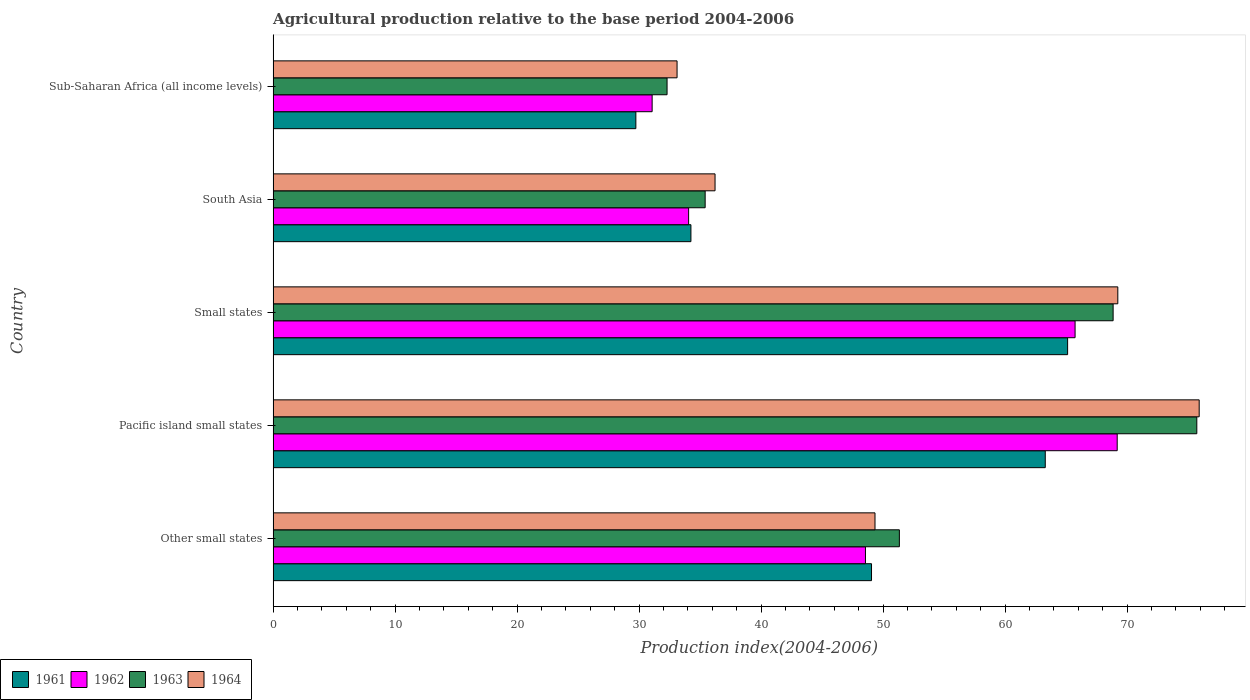How many different coloured bars are there?
Offer a very short reply. 4. How many groups of bars are there?
Offer a terse response. 5. Are the number of bars on each tick of the Y-axis equal?
Offer a terse response. Yes. How many bars are there on the 1st tick from the top?
Offer a terse response. 4. How many bars are there on the 2nd tick from the bottom?
Your response must be concise. 4. What is the label of the 3rd group of bars from the top?
Your response must be concise. Small states. In how many cases, is the number of bars for a given country not equal to the number of legend labels?
Your response must be concise. 0. What is the agricultural production index in 1963 in Other small states?
Ensure brevity in your answer.  51.34. Across all countries, what is the maximum agricultural production index in 1961?
Offer a very short reply. 65.13. Across all countries, what is the minimum agricultural production index in 1962?
Give a very brief answer. 31.07. In which country was the agricultural production index in 1963 maximum?
Give a very brief answer. Pacific island small states. In which country was the agricultural production index in 1961 minimum?
Offer a terse response. Sub-Saharan Africa (all income levels). What is the total agricultural production index in 1961 in the graph?
Offer a terse response. 241.47. What is the difference between the agricultural production index in 1963 in Pacific island small states and that in South Asia?
Provide a short and direct response. 40.31. What is the difference between the agricultural production index in 1963 in Sub-Saharan Africa (all income levels) and the agricultural production index in 1961 in Pacific island small states?
Ensure brevity in your answer.  -31. What is the average agricultural production index in 1963 per country?
Provide a short and direct response. 52.73. What is the difference between the agricultural production index in 1964 and agricultural production index in 1962 in Sub-Saharan Africa (all income levels)?
Make the answer very short. 2.04. In how many countries, is the agricultural production index in 1963 greater than 44 ?
Make the answer very short. 3. What is the ratio of the agricultural production index in 1963 in Small states to that in South Asia?
Your answer should be very brief. 1.94. Is the agricultural production index in 1962 in Other small states less than that in Pacific island small states?
Give a very brief answer. Yes. Is the difference between the agricultural production index in 1964 in Small states and Sub-Saharan Africa (all income levels) greater than the difference between the agricultural production index in 1962 in Small states and Sub-Saharan Africa (all income levels)?
Your answer should be compact. Yes. What is the difference between the highest and the second highest agricultural production index in 1961?
Your answer should be compact. 1.83. What is the difference between the highest and the lowest agricultural production index in 1961?
Offer a terse response. 35.39. In how many countries, is the agricultural production index in 1961 greater than the average agricultural production index in 1961 taken over all countries?
Your answer should be very brief. 3. Is it the case that in every country, the sum of the agricultural production index in 1964 and agricultural production index in 1963 is greater than the agricultural production index in 1961?
Provide a short and direct response. Yes. How many bars are there?
Give a very brief answer. 20. How many countries are there in the graph?
Offer a very short reply. 5. What is the difference between two consecutive major ticks on the X-axis?
Ensure brevity in your answer.  10. Does the graph contain any zero values?
Your answer should be compact. No. How are the legend labels stacked?
Your response must be concise. Horizontal. What is the title of the graph?
Ensure brevity in your answer.  Agricultural production relative to the base period 2004-2006. Does "1977" appear as one of the legend labels in the graph?
Your answer should be very brief. No. What is the label or title of the X-axis?
Offer a very short reply. Production index(2004-2006). What is the label or title of the Y-axis?
Offer a terse response. Country. What is the Production index(2004-2006) in 1961 in Other small states?
Offer a terse response. 49.06. What is the Production index(2004-2006) of 1962 in Other small states?
Your answer should be very brief. 48.56. What is the Production index(2004-2006) of 1963 in Other small states?
Offer a terse response. 51.34. What is the Production index(2004-2006) in 1964 in Other small states?
Give a very brief answer. 49.34. What is the Production index(2004-2006) of 1961 in Pacific island small states?
Give a very brief answer. 63.3. What is the Production index(2004-2006) of 1962 in Pacific island small states?
Offer a very short reply. 69.2. What is the Production index(2004-2006) of 1963 in Pacific island small states?
Keep it short and to the point. 75.72. What is the Production index(2004-2006) in 1964 in Pacific island small states?
Ensure brevity in your answer.  75.92. What is the Production index(2004-2006) in 1961 in Small states?
Your answer should be compact. 65.13. What is the Production index(2004-2006) in 1962 in Small states?
Ensure brevity in your answer.  65.74. What is the Production index(2004-2006) of 1963 in Small states?
Offer a very short reply. 68.86. What is the Production index(2004-2006) in 1964 in Small states?
Provide a short and direct response. 69.25. What is the Production index(2004-2006) of 1961 in South Asia?
Provide a succinct answer. 34.25. What is the Production index(2004-2006) of 1962 in South Asia?
Make the answer very short. 34.06. What is the Production index(2004-2006) in 1963 in South Asia?
Your answer should be very brief. 35.42. What is the Production index(2004-2006) of 1964 in South Asia?
Offer a terse response. 36.23. What is the Production index(2004-2006) of 1961 in Sub-Saharan Africa (all income levels)?
Ensure brevity in your answer.  29.74. What is the Production index(2004-2006) of 1962 in Sub-Saharan Africa (all income levels)?
Make the answer very short. 31.07. What is the Production index(2004-2006) in 1963 in Sub-Saharan Africa (all income levels)?
Ensure brevity in your answer.  32.29. What is the Production index(2004-2006) of 1964 in Sub-Saharan Africa (all income levels)?
Offer a terse response. 33.11. Across all countries, what is the maximum Production index(2004-2006) of 1961?
Make the answer very short. 65.13. Across all countries, what is the maximum Production index(2004-2006) of 1962?
Your response must be concise. 69.2. Across all countries, what is the maximum Production index(2004-2006) of 1963?
Provide a succinct answer. 75.72. Across all countries, what is the maximum Production index(2004-2006) of 1964?
Your answer should be very brief. 75.92. Across all countries, what is the minimum Production index(2004-2006) of 1961?
Offer a terse response. 29.74. Across all countries, what is the minimum Production index(2004-2006) in 1962?
Provide a short and direct response. 31.07. Across all countries, what is the minimum Production index(2004-2006) in 1963?
Provide a short and direct response. 32.29. Across all countries, what is the minimum Production index(2004-2006) in 1964?
Your answer should be compact. 33.11. What is the total Production index(2004-2006) in 1961 in the graph?
Your response must be concise. 241.47. What is the total Production index(2004-2006) in 1962 in the graph?
Keep it short and to the point. 248.63. What is the total Production index(2004-2006) in 1963 in the graph?
Provide a succinct answer. 263.64. What is the total Production index(2004-2006) in 1964 in the graph?
Make the answer very short. 263.85. What is the difference between the Production index(2004-2006) of 1961 in Other small states and that in Pacific island small states?
Provide a short and direct response. -14.24. What is the difference between the Production index(2004-2006) in 1962 in Other small states and that in Pacific island small states?
Make the answer very short. -20.64. What is the difference between the Production index(2004-2006) in 1963 in Other small states and that in Pacific island small states?
Provide a short and direct response. -24.38. What is the difference between the Production index(2004-2006) of 1964 in Other small states and that in Pacific island small states?
Your answer should be compact. -26.58. What is the difference between the Production index(2004-2006) in 1961 in Other small states and that in Small states?
Ensure brevity in your answer.  -16.08. What is the difference between the Production index(2004-2006) of 1962 in Other small states and that in Small states?
Provide a succinct answer. -17.18. What is the difference between the Production index(2004-2006) of 1963 in Other small states and that in Small states?
Your response must be concise. -17.52. What is the difference between the Production index(2004-2006) in 1964 in Other small states and that in Small states?
Keep it short and to the point. -19.91. What is the difference between the Production index(2004-2006) of 1961 in Other small states and that in South Asia?
Keep it short and to the point. 14.81. What is the difference between the Production index(2004-2006) of 1962 in Other small states and that in South Asia?
Keep it short and to the point. 14.5. What is the difference between the Production index(2004-2006) of 1963 in Other small states and that in South Asia?
Offer a terse response. 15.92. What is the difference between the Production index(2004-2006) of 1964 in Other small states and that in South Asia?
Your answer should be very brief. 13.11. What is the difference between the Production index(2004-2006) of 1961 in Other small states and that in Sub-Saharan Africa (all income levels)?
Ensure brevity in your answer.  19.32. What is the difference between the Production index(2004-2006) of 1962 in Other small states and that in Sub-Saharan Africa (all income levels)?
Give a very brief answer. 17.49. What is the difference between the Production index(2004-2006) of 1963 in Other small states and that in Sub-Saharan Africa (all income levels)?
Your answer should be very brief. 19.04. What is the difference between the Production index(2004-2006) of 1964 in Other small states and that in Sub-Saharan Africa (all income levels)?
Offer a very short reply. 16.23. What is the difference between the Production index(2004-2006) in 1961 in Pacific island small states and that in Small states?
Provide a succinct answer. -1.83. What is the difference between the Production index(2004-2006) of 1962 in Pacific island small states and that in Small states?
Ensure brevity in your answer.  3.45. What is the difference between the Production index(2004-2006) of 1963 in Pacific island small states and that in Small states?
Offer a very short reply. 6.86. What is the difference between the Production index(2004-2006) in 1964 in Pacific island small states and that in Small states?
Your answer should be compact. 6.67. What is the difference between the Production index(2004-2006) of 1961 in Pacific island small states and that in South Asia?
Provide a succinct answer. 29.05. What is the difference between the Production index(2004-2006) in 1962 in Pacific island small states and that in South Asia?
Provide a short and direct response. 35.13. What is the difference between the Production index(2004-2006) in 1963 in Pacific island small states and that in South Asia?
Your answer should be compact. 40.31. What is the difference between the Production index(2004-2006) of 1964 in Pacific island small states and that in South Asia?
Provide a succinct answer. 39.69. What is the difference between the Production index(2004-2006) in 1961 in Pacific island small states and that in Sub-Saharan Africa (all income levels)?
Your response must be concise. 33.56. What is the difference between the Production index(2004-2006) in 1962 in Pacific island small states and that in Sub-Saharan Africa (all income levels)?
Your answer should be compact. 38.12. What is the difference between the Production index(2004-2006) in 1963 in Pacific island small states and that in Sub-Saharan Africa (all income levels)?
Ensure brevity in your answer.  43.43. What is the difference between the Production index(2004-2006) of 1964 in Pacific island small states and that in Sub-Saharan Africa (all income levels)?
Provide a short and direct response. 42.8. What is the difference between the Production index(2004-2006) of 1961 in Small states and that in South Asia?
Ensure brevity in your answer.  30.88. What is the difference between the Production index(2004-2006) of 1962 in Small states and that in South Asia?
Give a very brief answer. 31.68. What is the difference between the Production index(2004-2006) of 1963 in Small states and that in South Asia?
Offer a terse response. 33.45. What is the difference between the Production index(2004-2006) of 1964 in Small states and that in South Asia?
Make the answer very short. 33.02. What is the difference between the Production index(2004-2006) in 1961 in Small states and that in Sub-Saharan Africa (all income levels)?
Your answer should be compact. 35.39. What is the difference between the Production index(2004-2006) of 1962 in Small states and that in Sub-Saharan Africa (all income levels)?
Offer a terse response. 34.67. What is the difference between the Production index(2004-2006) in 1963 in Small states and that in Sub-Saharan Africa (all income levels)?
Offer a very short reply. 36.57. What is the difference between the Production index(2004-2006) in 1964 in Small states and that in Sub-Saharan Africa (all income levels)?
Make the answer very short. 36.13. What is the difference between the Production index(2004-2006) of 1961 in South Asia and that in Sub-Saharan Africa (all income levels)?
Ensure brevity in your answer.  4.51. What is the difference between the Production index(2004-2006) in 1962 in South Asia and that in Sub-Saharan Africa (all income levels)?
Ensure brevity in your answer.  2.99. What is the difference between the Production index(2004-2006) of 1963 in South Asia and that in Sub-Saharan Africa (all income levels)?
Give a very brief answer. 3.12. What is the difference between the Production index(2004-2006) in 1964 in South Asia and that in Sub-Saharan Africa (all income levels)?
Your response must be concise. 3.11. What is the difference between the Production index(2004-2006) in 1961 in Other small states and the Production index(2004-2006) in 1962 in Pacific island small states?
Your answer should be compact. -20.14. What is the difference between the Production index(2004-2006) in 1961 in Other small states and the Production index(2004-2006) in 1963 in Pacific island small states?
Keep it short and to the point. -26.67. What is the difference between the Production index(2004-2006) of 1961 in Other small states and the Production index(2004-2006) of 1964 in Pacific island small states?
Offer a terse response. -26.86. What is the difference between the Production index(2004-2006) in 1962 in Other small states and the Production index(2004-2006) in 1963 in Pacific island small states?
Ensure brevity in your answer.  -27.16. What is the difference between the Production index(2004-2006) in 1962 in Other small states and the Production index(2004-2006) in 1964 in Pacific island small states?
Offer a terse response. -27.36. What is the difference between the Production index(2004-2006) of 1963 in Other small states and the Production index(2004-2006) of 1964 in Pacific island small states?
Offer a terse response. -24.58. What is the difference between the Production index(2004-2006) in 1961 in Other small states and the Production index(2004-2006) in 1962 in Small states?
Your answer should be very brief. -16.69. What is the difference between the Production index(2004-2006) of 1961 in Other small states and the Production index(2004-2006) of 1963 in Small states?
Offer a very short reply. -19.81. What is the difference between the Production index(2004-2006) in 1961 in Other small states and the Production index(2004-2006) in 1964 in Small states?
Give a very brief answer. -20.19. What is the difference between the Production index(2004-2006) of 1962 in Other small states and the Production index(2004-2006) of 1963 in Small states?
Ensure brevity in your answer.  -20.3. What is the difference between the Production index(2004-2006) of 1962 in Other small states and the Production index(2004-2006) of 1964 in Small states?
Keep it short and to the point. -20.69. What is the difference between the Production index(2004-2006) of 1963 in Other small states and the Production index(2004-2006) of 1964 in Small states?
Give a very brief answer. -17.91. What is the difference between the Production index(2004-2006) of 1961 in Other small states and the Production index(2004-2006) of 1962 in South Asia?
Give a very brief answer. 14.99. What is the difference between the Production index(2004-2006) of 1961 in Other small states and the Production index(2004-2006) of 1963 in South Asia?
Keep it short and to the point. 13.64. What is the difference between the Production index(2004-2006) in 1961 in Other small states and the Production index(2004-2006) in 1964 in South Asia?
Offer a very short reply. 12.83. What is the difference between the Production index(2004-2006) in 1962 in Other small states and the Production index(2004-2006) in 1963 in South Asia?
Your answer should be very brief. 13.14. What is the difference between the Production index(2004-2006) in 1962 in Other small states and the Production index(2004-2006) in 1964 in South Asia?
Provide a succinct answer. 12.33. What is the difference between the Production index(2004-2006) in 1963 in Other small states and the Production index(2004-2006) in 1964 in South Asia?
Your answer should be compact. 15.11. What is the difference between the Production index(2004-2006) of 1961 in Other small states and the Production index(2004-2006) of 1962 in Sub-Saharan Africa (all income levels)?
Give a very brief answer. 17.98. What is the difference between the Production index(2004-2006) in 1961 in Other small states and the Production index(2004-2006) in 1963 in Sub-Saharan Africa (all income levels)?
Provide a short and direct response. 16.76. What is the difference between the Production index(2004-2006) of 1961 in Other small states and the Production index(2004-2006) of 1964 in Sub-Saharan Africa (all income levels)?
Give a very brief answer. 15.94. What is the difference between the Production index(2004-2006) of 1962 in Other small states and the Production index(2004-2006) of 1963 in Sub-Saharan Africa (all income levels)?
Your answer should be very brief. 16.27. What is the difference between the Production index(2004-2006) in 1962 in Other small states and the Production index(2004-2006) in 1964 in Sub-Saharan Africa (all income levels)?
Make the answer very short. 15.45. What is the difference between the Production index(2004-2006) of 1963 in Other small states and the Production index(2004-2006) of 1964 in Sub-Saharan Africa (all income levels)?
Make the answer very short. 18.22. What is the difference between the Production index(2004-2006) in 1961 in Pacific island small states and the Production index(2004-2006) in 1962 in Small states?
Keep it short and to the point. -2.44. What is the difference between the Production index(2004-2006) of 1961 in Pacific island small states and the Production index(2004-2006) of 1963 in Small states?
Ensure brevity in your answer.  -5.56. What is the difference between the Production index(2004-2006) of 1961 in Pacific island small states and the Production index(2004-2006) of 1964 in Small states?
Ensure brevity in your answer.  -5.95. What is the difference between the Production index(2004-2006) in 1962 in Pacific island small states and the Production index(2004-2006) in 1963 in Small states?
Provide a succinct answer. 0.33. What is the difference between the Production index(2004-2006) in 1962 in Pacific island small states and the Production index(2004-2006) in 1964 in Small states?
Offer a very short reply. -0.05. What is the difference between the Production index(2004-2006) of 1963 in Pacific island small states and the Production index(2004-2006) of 1964 in Small states?
Ensure brevity in your answer.  6.48. What is the difference between the Production index(2004-2006) in 1961 in Pacific island small states and the Production index(2004-2006) in 1962 in South Asia?
Make the answer very short. 29.24. What is the difference between the Production index(2004-2006) of 1961 in Pacific island small states and the Production index(2004-2006) of 1963 in South Asia?
Make the answer very short. 27.88. What is the difference between the Production index(2004-2006) in 1961 in Pacific island small states and the Production index(2004-2006) in 1964 in South Asia?
Keep it short and to the point. 27.07. What is the difference between the Production index(2004-2006) in 1962 in Pacific island small states and the Production index(2004-2006) in 1963 in South Asia?
Give a very brief answer. 33.78. What is the difference between the Production index(2004-2006) in 1962 in Pacific island small states and the Production index(2004-2006) in 1964 in South Asia?
Make the answer very short. 32.97. What is the difference between the Production index(2004-2006) of 1963 in Pacific island small states and the Production index(2004-2006) of 1964 in South Asia?
Ensure brevity in your answer.  39.49. What is the difference between the Production index(2004-2006) of 1961 in Pacific island small states and the Production index(2004-2006) of 1962 in Sub-Saharan Africa (all income levels)?
Provide a succinct answer. 32.23. What is the difference between the Production index(2004-2006) of 1961 in Pacific island small states and the Production index(2004-2006) of 1963 in Sub-Saharan Africa (all income levels)?
Offer a terse response. 31. What is the difference between the Production index(2004-2006) of 1961 in Pacific island small states and the Production index(2004-2006) of 1964 in Sub-Saharan Africa (all income levels)?
Give a very brief answer. 30.18. What is the difference between the Production index(2004-2006) in 1962 in Pacific island small states and the Production index(2004-2006) in 1963 in Sub-Saharan Africa (all income levels)?
Your answer should be compact. 36.9. What is the difference between the Production index(2004-2006) in 1962 in Pacific island small states and the Production index(2004-2006) in 1964 in Sub-Saharan Africa (all income levels)?
Offer a terse response. 36.08. What is the difference between the Production index(2004-2006) in 1963 in Pacific island small states and the Production index(2004-2006) in 1964 in Sub-Saharan Africa (all income levels)?
Keep it short and to the point. 42.61. What is the difference between the Production index(2004-2006) of 1961 in Small states and the Production index(2004-2006) of 1962 in South Asia?
Make the answer very short. 31.07. What is the difference between the Production index(2004-2006) of 1961 in Small states and the Production index(2004-2006) of 1963 in South Asia?
Make the answer very short. 29.71. What is the difference between the Production index(2004-2006) in 1961 in Small states and the Production index(2004-2006) in 1964 in South Asia?
Provide a succinct answer. 28.9. What is the difference between the Production index(2004-2006) in 1962 in Small states and the Production index(2004-2006) in 1963 in South Asia?
Your response must be concise. 30.33. What is the difference between the Production index(2004-2006) of 1962 in Small states and the Production index(2004-2006) of 1964 in South Asia?
Your response must be concise. 29.51. What is the difference between the Production index(2004-2006) in 1963 in Small states and the Production index(2004-2006) in 1964 in South Asia?
Provide a short and direct response. 32.63. What is the difference between the Production index(2004-2006) in 1961 in Small states and the Production index(2004-2006) in 1962 in Sub-Saharan Africa (all income levels)?
Offer a very short reply. 34.06. What is the difference between the Production index(2004-2006) in 1961 in Small states and the Production index(2004-2006) in 1963 in Sub-Saharan Africa (all income levels)?
Keep it short and to the point. 32.84. What is the difference between the Production index(2004-2006) in 1961 in Small states and the Production index(2004-2006) in 1964 in Sub-Saharan Africa (all income levels)?
Make the answer very short. 32.02. What is the difference between the Production index(2004-2006) of 1962 in Small states and the Production index(2004-2006) of 1963 in Sub-Saharan Africa (all income levels)?
Your answer should be compact. 33.45. What is the difference between the Production index(2004-2006) of 1962 in Small states and the Production index(2004-2006) of 1964 in Sub-Saharan Africa (all income levels)?
Provide a short and direct response. 32.63. What is the difference between the Production index(2004-2006) in 1963 in Small states and the Production index(2004-2006) in 1964 in Sub-Saharan Africa (all income levels)?
Make the answer very short. 35.75. What is the difference between the Production index(2004-2006) in 1961 in South Asia and the Production index(2004-2006) in 1962 in Sub-Saharan Africa (all income levels)?
Your response must be concise. 3.18. What is the difference between the Production index(2004-2006) of 1961 in South Asia and the Production index(2004-2006) of 1963 in Sub-Saharan Africa (all income levels)?
Provide a short and direct response. 1.96. What is the difference between the Production index(2004-2006) in 1961 in South Asia and the Production index(2004-2006) in 1964 in Sub-Saharan Africa (all income levels)?
Provide a short and direct response. 1.14. What is the difference between the Production index(2004-2006) of 1962 in South Asia and the Production index(2004-2006) of 1963 in Sub-Saharan Africa (all income levels)?
Offer a terse response. 1.77. What is the difference between the Production index(2004-2006) in 1962 in South Asia and the Production index(2004-2006) in 1964 in Sub-Saharan Africa (all income levels)?
Your answer should be very brief. 0.95. What is the difference between the Production index(2004-2006) in 1963 in South Asia and the Production index(2004-2006) in 1964 in Sub-Saharan Africa (all income levels)?
Keep it short and to the point. 2.3. What is the average Production index(2004-2006) in 1961 per country?
Offer a terse response. 48.29. What is the average Production index(2004-2006) of 1962 per country?
Your answer should be very brief. 49.73. What is the average Production index(2004-2006) of 1963 per country?
Ensure brevity in your answer.  52.73. What is the average Production index(2004-2006) in 1964 per country?
Your answer should be compact. 52.77. What is the difference between the Production index(2004-2006) in 1961 and Production index(2004-2006) in 1962 in Other small states?
Your answer should be very brief. 0.5. What is the difference between the Production index(2004-2006) in 1961 and Production index(2004-2006) in 1963 in Other small states?
Provide a short and direct response. -2.28. What is the difference between the Production index(2004-2006) in 1961 and Production index(2004-2006) in 1964 in Other small states?
Ensure brevity in your answer.  -0.28. What is the difference between the Production index(2004-2006) in 1962 and Production index(2004-2006) in 1963 in Other small states?
Offer a terse response. -2.78. What is the difference between the Production index(2004-2006) in 1962 and Production index(2004-2006) in 1964 in Other small states?
Provide a short and direct response. -0.78. What is the difference between the Production index(2004-2006) in 1963 and Production index(2004-2006) in 1964 in Other small states?
Ensure brevity in your answer.  2. What is the difference between the Production index(2004-2006) in 1961 and Production index(2004-2006) in 1962 in Pacific island small states?
Make the answer very short. -5.9. What is the difference between the Production index(2004-2006) of 1961 and Production index(2004-2006) of 1963 in Pacific island small states?
Keep it short and to the point. -12.42. What is the difference between the Production index(2004-2006) in 1961 and Production index(2004-2006) in 1964 in Pacific island small states?
Provide a short and direct response. -12.62. What is the difference between the Production index(2004-2006) in 1962 and Production index(2004-2006) in 1963 in Pacific island small states?
Ensure brevity in your answer.  -6.53. What is the difference between the Production index(2004-2006) in 1962 and Production index(2004-2006) in 1964 in Pacific island small states?
Ensure brevity in your answer.  -6.72. What is the difference between the Production index(2004-2006) in 1963 and Production index(2004-2006) in 1964 in Pacific island small states?
Your answer should be compact. -0.19. What is the difference between the Production index(2004-2006) in 1961 and Production index(2004-2006) in 1962 in Small states?
Provide a succinct answer. -0.61. What is the difference between the Production index(2004-2006) of 1961 and Production index(2004-2006) of 1963 in Small states?
Give a very brief answer. -3.73. What is the difference between the Production index(2004-2006) in 1961 and Production index(2004-2006) in 1964 in Small states?
Your answer should be very brief. -4.11. What is the difference between the Production index(2004-2006) in 1962 and Production index(2004-2006) in 1963 in Small states?
Provide a short and direct response. -3.12. What is the difference between the Production index(2004-2006) of 1962 and Production index(2004-2006) of 1964 in Small states?
Provide a short and direct response. -3.5. What is the difference between the Production index(2004-2006) in 1963 and Production index(2004-2006) in 1964 in Small states?
Ensure brevity in your answer.  -0.38. What is the difference between the Production index(2004-2006) in 1961 and Production index(2004-2006) in 1962 in South Asia?
Offer a terse response. 0.19. What is the difference between the Production index(2004-2006) in 1961 and Production index(2004-2006) in 1963 in South Asia?
Your answer should be very brief. -1.17. What is the difference between the Production index(2004-2006) in 1961 and Production index(2004-2006) in 1964 in South Asia?
Offer a terse response. -1.98. What is the difference between the Production index(2004-2006) in 1962 and Production index(2004-2006) in 1963 in South Asia?
Make the answer very short. -1.35. What is the difference between the Production index(2004-2006) of 1962 and Production index(2004-2006) of 1964 in South Asia?
Your answer should be very brief. -2.17. What is the difference between the Production index(2004-2006) in 1963 and Production index(2004-2006) in 1964 in South Asia?
Ensure brevity in your answer.  -0.81. What is the difference between the Production index(2004-2006) of 1961 and Production index(2004-2006) of 1962 in Sub-Saharan Africa (all income levels)?
Your answer should be very brief. -1.33. What is the difference between the Production index(2004-2006) of 1961 and Production index(2004-2006) of 1963 in Sub-Saharan Africa (all income levels)?
Your answer should be very brief. -2.56. What is the difference between the Production index(2004-2006) of 1961 and Production index(2004-2006) of 1964 in Sub-Saharan Africa (all income levels)?
Provide a short and direct response. -3.38. What is the difference between the Production index(2004-2006) of 1962 and Production index(2004-2006) of 1963 in Sub-Saharan Africa (all income levels)?
Keep it short and to the point. -1.22. What is the difference between the Production index(2004-2006) in 1962 and Production index(2004-2006) in 1964 in Sub-Saharan Africa (all income levels)?
Provide a succinct answer. -2.04. What is the difference between the Production index(2004-2006) in 1963 and Production index(2004-2006) in 1964 in Sub-Saharan Africa (all income levels)?
Your response must be concise. -0.82. What is the ratio of the Production index(2004-2006) in 1961 in Other small states to that in Pacific island small states?
Offer a terse response. 0.78. What is the ratio of the Production index(2004-2006) of 1962 in Other small states to that in Pacific island small states?
Offer a very short reply. 0.7. What is the ratio of the Production index(2004-2006) of 1963 in Other small states to that in Pacific island small states?
Offer a very short reply. 0.68. What is the ratio of the Production index(2004-2006) in 1964 in Other small states to that in Pacific island small states?
Offer a terse response. 0.65. What is the ratio of the Production index(2004-2006) in 1961 in Other small states to that in Small states?
Your response must be concise. 0.75. What is the ratio of the Production index(2004-2006) in 1962 in Other small states to that in Small states?
Offer a terse response. 0.74. What is the ratio of the Production index(2004-2006) of 1963 in Other small states to that in Small states?
Offer a very short reply. 0.75. What is the ratio of the Production index(2004-2006) of 1964 in Other small states to that in Small states?
Offer a terse response. 0.71. What is the ratio of the Production index(2004-2006) of 1961 in Other small states to that in South Asia?
Your response must be concise. 1.43. What is the ratio of the Production index(2004-2006) of 1962 in Other small states to that in South Asia?
Make the answer very short. 1.43. What is the ratio of the Production index(2004-2006) in 1963 in Other small states to that in South Asia?
Make the answer very short. 1.45. What is the ratio of the Production index(2004-2006) of 1964 in Other small states to that in South Asia?
Your answer should be compact. 1.36. What is the ratio of the Production index(2004-2006) in 1961 in Other small states to that in Sub-Saharan Africa (all income levels)?
Provide a succinct answer. 1.65. What is the ratio of the Production index(2004-2006) of 1962 in Other small states to that in Sub-Saharan Africa (all income levels)?
Ensure brevity in your answer.  1.56. What is the ratio of the Production index(2004-2006) in 1963 in Other small states to that in Sub-Saharan Africa (all income levels)?
Your answer should be very brief. 1.59. What is the ratio of the Production index(2004-2006) in 1964 in Other small states to that in Sub-Saharan Africa (all income levels)?
Make the answer very short. 1.49. What is the ratio of the Production index(2004-2006) in 1961 in Pacific island small states to that in Small states?
Offer a very short reply. 0.97. What is the ratio of the Production index(2004-2006) of 1962 in Pacific island small states to that in Small states?
Your answer should be compact. 1.05. What is the ratio of the Production index(2004-2006) in 1963 in Pacific island small states to that in Small states?
Your answer should be compact. 1.1. What is the ratio of the Production index(2004-2006) of 1964 in Pacific island small states to that in Small states?
Your answer should be compact. 1.1. What is the ratio of the Production index(2004-2006) in 1961 in Pacific island small states to that in South Asia?
Give a very brief answer. 1.85. What is the ratio of the Production index(2004-2006) in 1962 in Pacific island small states to that in South Asia?
Provide a short and direct response. 2.03. What is the ratio of the Production index(2004-2006) in 1963 in Pacific island small states to that in South Asia?
Provide a short and direct response. 2.14. What is the ratio of the Production index(2004-2006) of 1964 in Pacific island small states to that in South Asia?
Make the answer very short. 2.1. What is the ratio of the Production index(2004-2006) of 1961 in Pacific island small states to that in Sub-Saharan Africa (all income levels)?
Give a very brief answer. 2.13. What is the ratio of the Production index(2004-2006) of 1962 in Pacific island small states to that in Sub-Saharan Africa (all income levels)?
Make the answer very short. 2.23. What is the ratio of the Production index(2004-2006) in 1963 in Pacific island small states to that in Sub-Saharan Africa (all income levels)?
Keep it short and to the point. 2.34. What is the ratio of the Production index(2004-2006) of 1964 in Pacific island small states to that in Sub-Saharan Africa (all income levels)?
Provide a succinct answer. 2.29. What is the ratio of the Production index(2004-2006) in 1961 in Small states to that in South Asia?
Your answer should be compact. 1.9. What is the ratio of the Production index(2004-2006) of 1962 in Small states to that in South Asia?
Give a very brief answer. 1.93. What is the ratio of the Production index(2004-2006) in 1963 in Small states to that in South Asia?
Your answer should be compact. 1.94. What is the ratio of the Production index(2004-2006) in 1964 in Small states to that in South Asia?
Keep it short and to the point. 1.91. What is the ratio of the Production index(2004-2006) in 1961 in Small states to that in Sub-Saharan Africa (all income levels)?
Make the answer very short. 2.19. What is the ratio of the Production index(2004-2006) of 1962 in Small states to that in Sub-Saharan Africa (all income levels)?
Keep it short and to the point. 2.12. What is the ratio of the Production index(2004-2006) in 1963 in Small states to that in Sub-Saharan Africa (all income levels)?
Offer a terse response. 2.13. What is the ratio of the Production index(2004-2006) of 1964 in Small states to that in Sub-Saharan Africa (all income levels)?
Give a very brief answer. 2.09. What is the ratio of the Production index(2004-2006) of 1961 in South Asia to that in Sub-Saharan Africa (all income levels)?
Provide a short and direct response. 1.15. What is the ratio of the Production index(2004-2006) in 1962 in South Asia to that in Sub-Saharan Africa (all income levels)?
Your response must be concise. 1.1. What is the ratio of the Production index(2004-2006) in 1963 in South Asia to that in Sub-Saharan Africa (all income levels)?
Provide a succinct answer. 1.1. What is the ratio of the Production index(2004-2006) in 1964 in South Asia to that in Sub-Saharan Africa (all income levels)?
Your response must be concise. 1.09. What is the difference between the highest and the second highest Production index(2004-2006) of 1961?
Your response must be concise. 1.83. What is the difference between the highest and the second highest Production index(2004-2006) of 1962?
Give a very brief answer. 3.45. What is the difference between the highest and the second highest Production index(2004-2006) in 1963?
Give a very brief answer. 6.86. What is the difference between the highest and the second highest Production index(2004-2006) in 1964?
Offer a terse response. 6.67. What is the difference between the highest and the lowest Production index(2004-2006) in 1961?
Make the answer very short. 35.39. What is the difference between the highest and the lowest Production index(2004-2006) in 1962?
Your response must be concise. 38.12. What is the difference between the highest and the lowest Production index(2004-2006) in 1963?
Offer a terse response. 43.43. What is the difference between the highest and the lowest Production index(2004-2006) in 1964?
Provide a succinct answer. 42.8. 